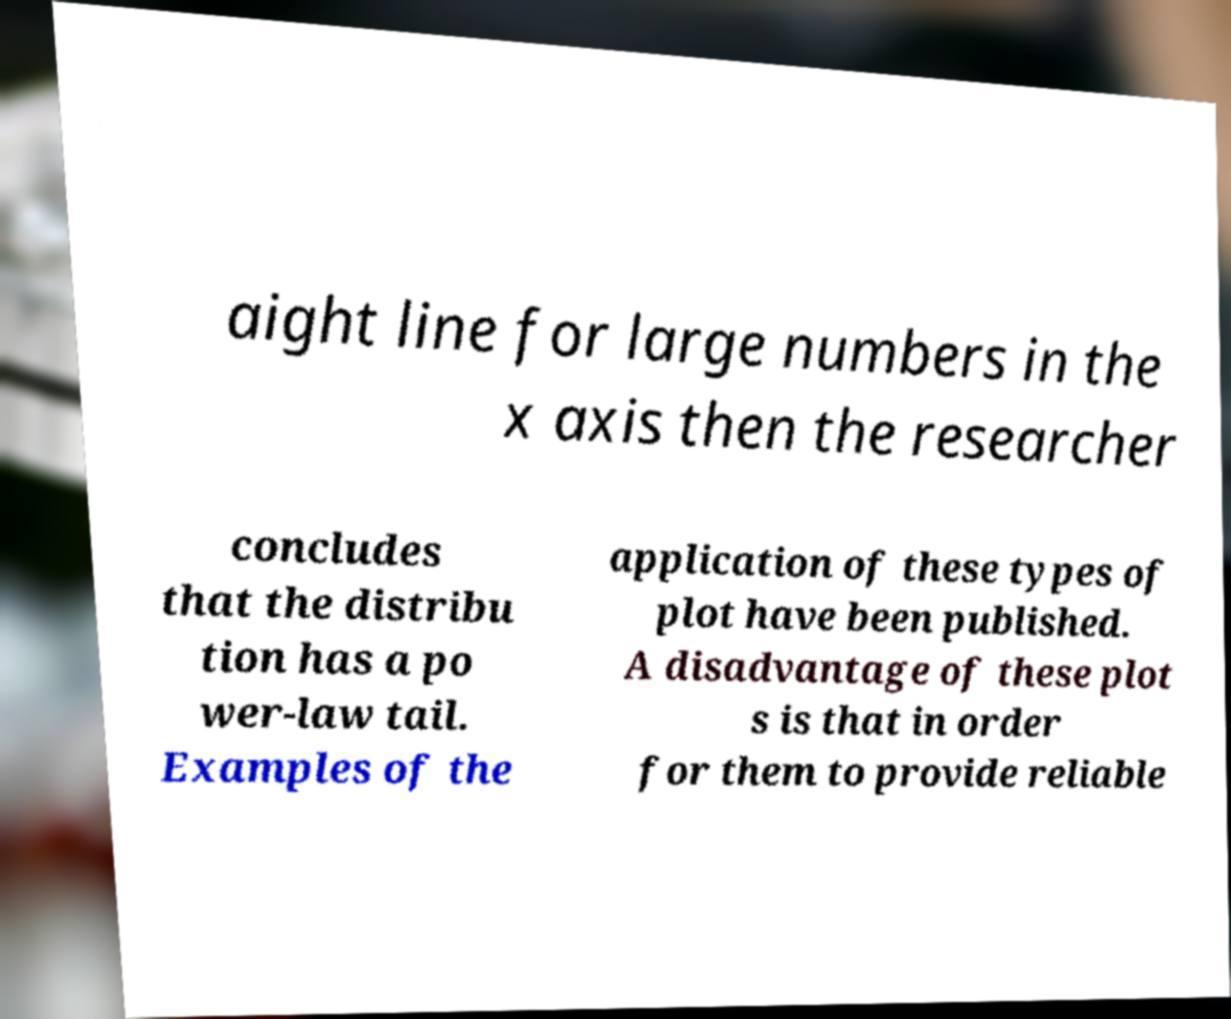What messages or text are displayed in this image? I need them in a readable, typed format. aight line for large numbers in the x axis then the researcher concludes that the distribu tion has a po wer-law tail. Examples of the application of these types of plot have been published. A disadvantage of these plot s is that in order for them to provide reliable 